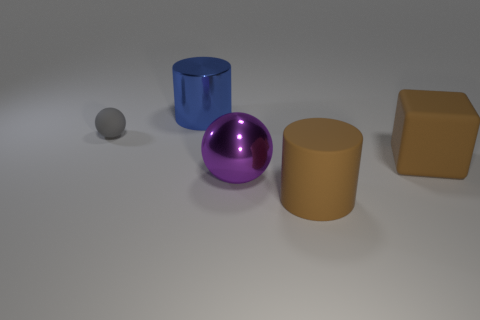Is there anything else that has the same size as the gray thing?
Ensure brevity in your answer.  No. There is a metallic thing that is on the right side of the cylinder that is behind the large brown cylinder; how many blue metal things are left of it?
Your answer should be very brief. 1. Are there more tiny balls that are on the right side of the big matte cube than purple spheres behind the purple ball?
Provide a short and direct response. No. What number of blue things are the same shape as the tiny gray object?
Offer a very short reply. 0. What number of things are either large things behind the large purple sphere or rubber objects in front of the gray ball?
Offer a very short reply. 3. The object in front of the large metal thing in front of the ball that is on the left side of the purple sphere is made of what material?
Ensure brevity in your answer.  Rubber. Is the color of the large rubber object in front of the large metal ball the same as the tiny rubber sphere?
Ensure brevity in your answer.  No. There is a large object that is left of the large brown rubber cylinder and in front of the gray matte ball; what is its material?
Your answer should be very brief. Metal. Are there any red matte balls that have the same size as the rubber cylinder?
Give a very brief answer. No. How many brown matte things are there?
Ensure brevity in your answer.  2. 